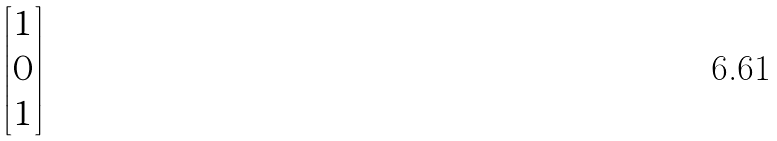Convert formula to latex. <formula><loc_0><loc_0><loc_500><loc_500>\begin{bmatrix} 1 \\ 0 \\ 1 \end{bmatrix}</formula> 